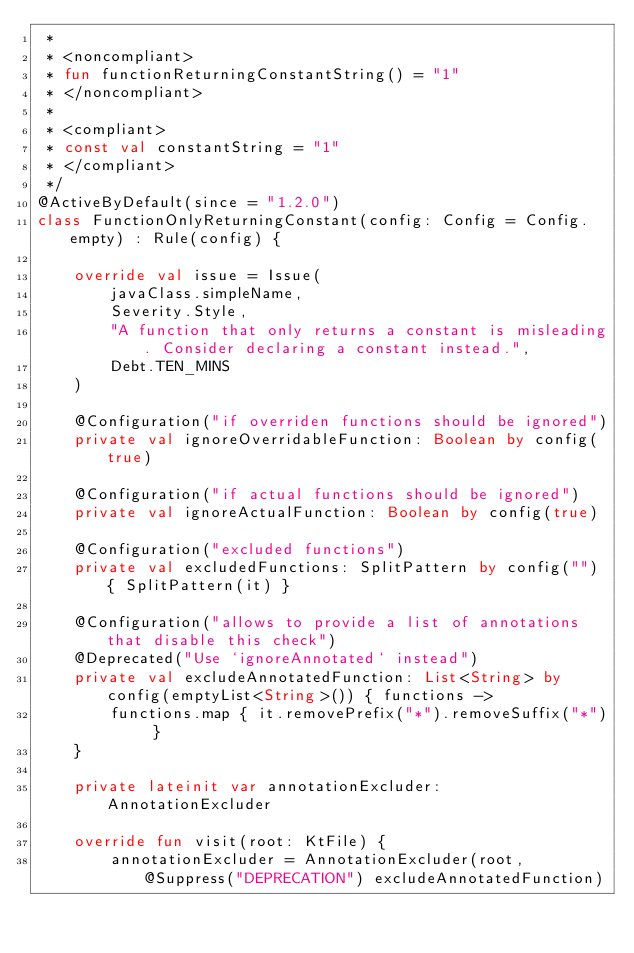<code> <loc_0><loc_0><loc_500><loc_500><_Kotlin_> *
 * <noncompliant>
 * fun functionReturningConstantString() = "1"
 * </noncompliant>
 *
 * <compliant>
 * const val constantString = "1"
 * </compliant>
 */
@ActiveByDefault(since = "1.2.0")
class FunctionOnlyReturningConstant(config: Config = Config.empty) : Rule(config) {

    override val issue = Issue(
        javaClass.simpleName,
        Severity.Style,
        "A function that only returns a constant is misleading. Consider declaring a constant instead.",
        Debt.TEN_MINS
    )

    @Configuration("if overriden functions should be ignored")
    private val ignoreOverridableFunction: Boolean by config(true)

    @Configuration("if actual functions should be ignored")
    private val ignoreActualFunction: Boolean by config(true)

    @Configuration("excluded functions")
    private val excludedFunctions: SplitPattern by config("") { SplitPattern(it) }

    @Configuration("allows to provide a list of annotations that disable this check")
    @Deprecated("Use `ignoreAnnotated` instead")
    private val excludeAnnotatedFunction: List<String> by config(emptyList<String>()) { functions ->
        functions.map { it.removePrefix("*").removeSuffix("*") }
    }

    private lateinit var annotationExcluder: AnnotationExcluder

    override fun visit(root: KtFile) {
        annotationExcluder = AnnotationExcluder(root, @Suppress("DEPRECATION") excludeAnnotatedFunction)</code> 